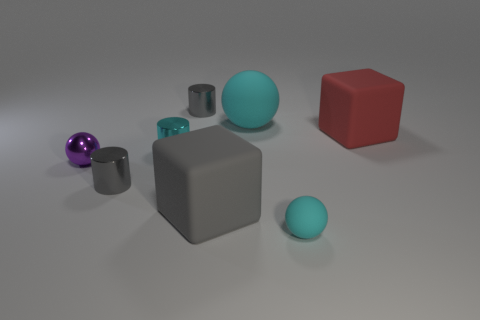Add 1 gray metallic cylinders. How many objects exist? 9 Subtract all cubes. How many objects are left? 6 Subtract 1 gray cylinders. How many objects are left? 7 Subtract all shiny cylinders. Subtract all big gray cubes. How many objects are left? 4 Add 7 rubber balls. How many rubber balls are left? 9 Add 2 big cyan metal spheres. How many big cyan metal spheres exist? 2 